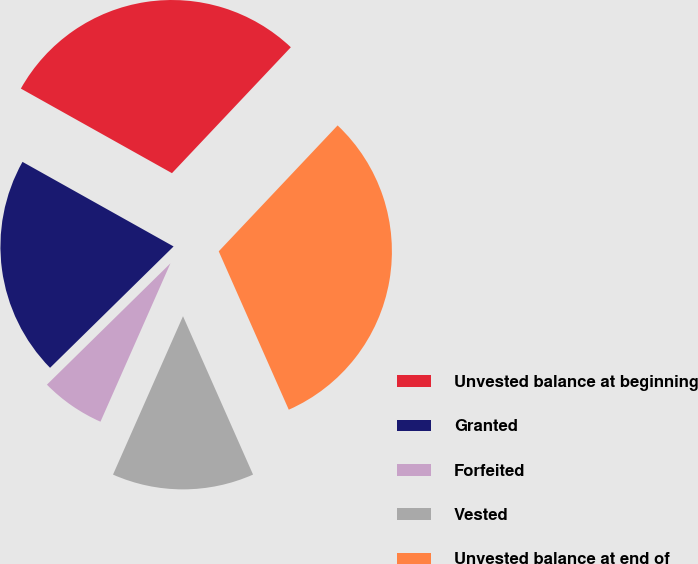Convert chart to OTSL. <chart><loc_0><loc_0><loc_500><loc_500><pie_chart><fcel>Unvested balance at beginning<fcel>Granted<fcel>Forfeited<fcel>Vested<fcel>Unvested balance at end of<nl><fcel>28.92%<fcel>20.48%<fcel>6.02%<fcel>13.25%<fcel>31.33%<nl></chart> 